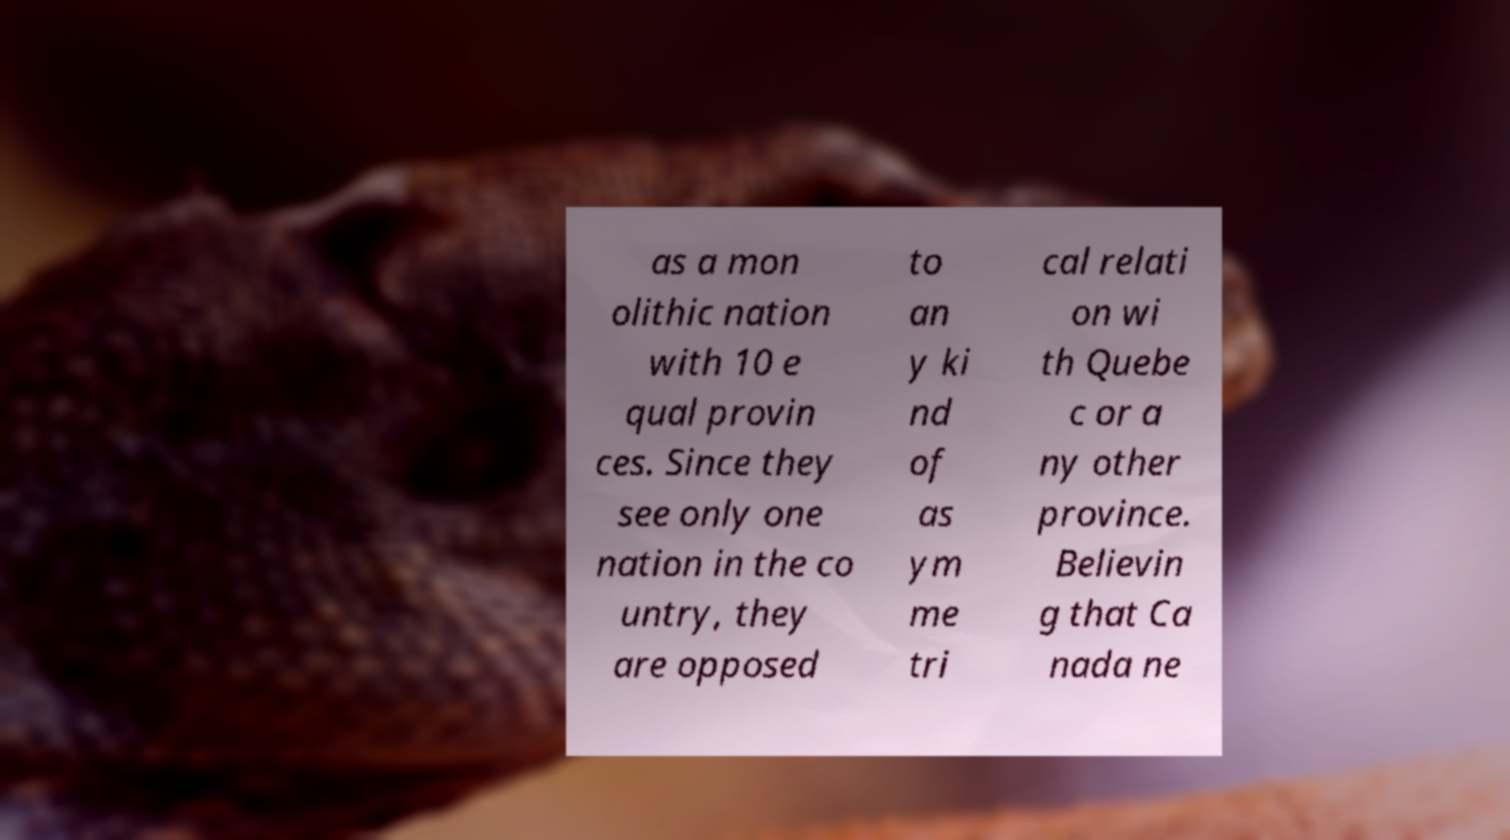Please read and relay the text visible in this image. What does it say? as a mon olithic nation with 10 e qual provin ces. Since they see only one nation in the co untry, they are opposed to an y ki nd of as ym me tri cal relati on wi th Quebe c or a ny other province. Believin g that Ca nada ne 